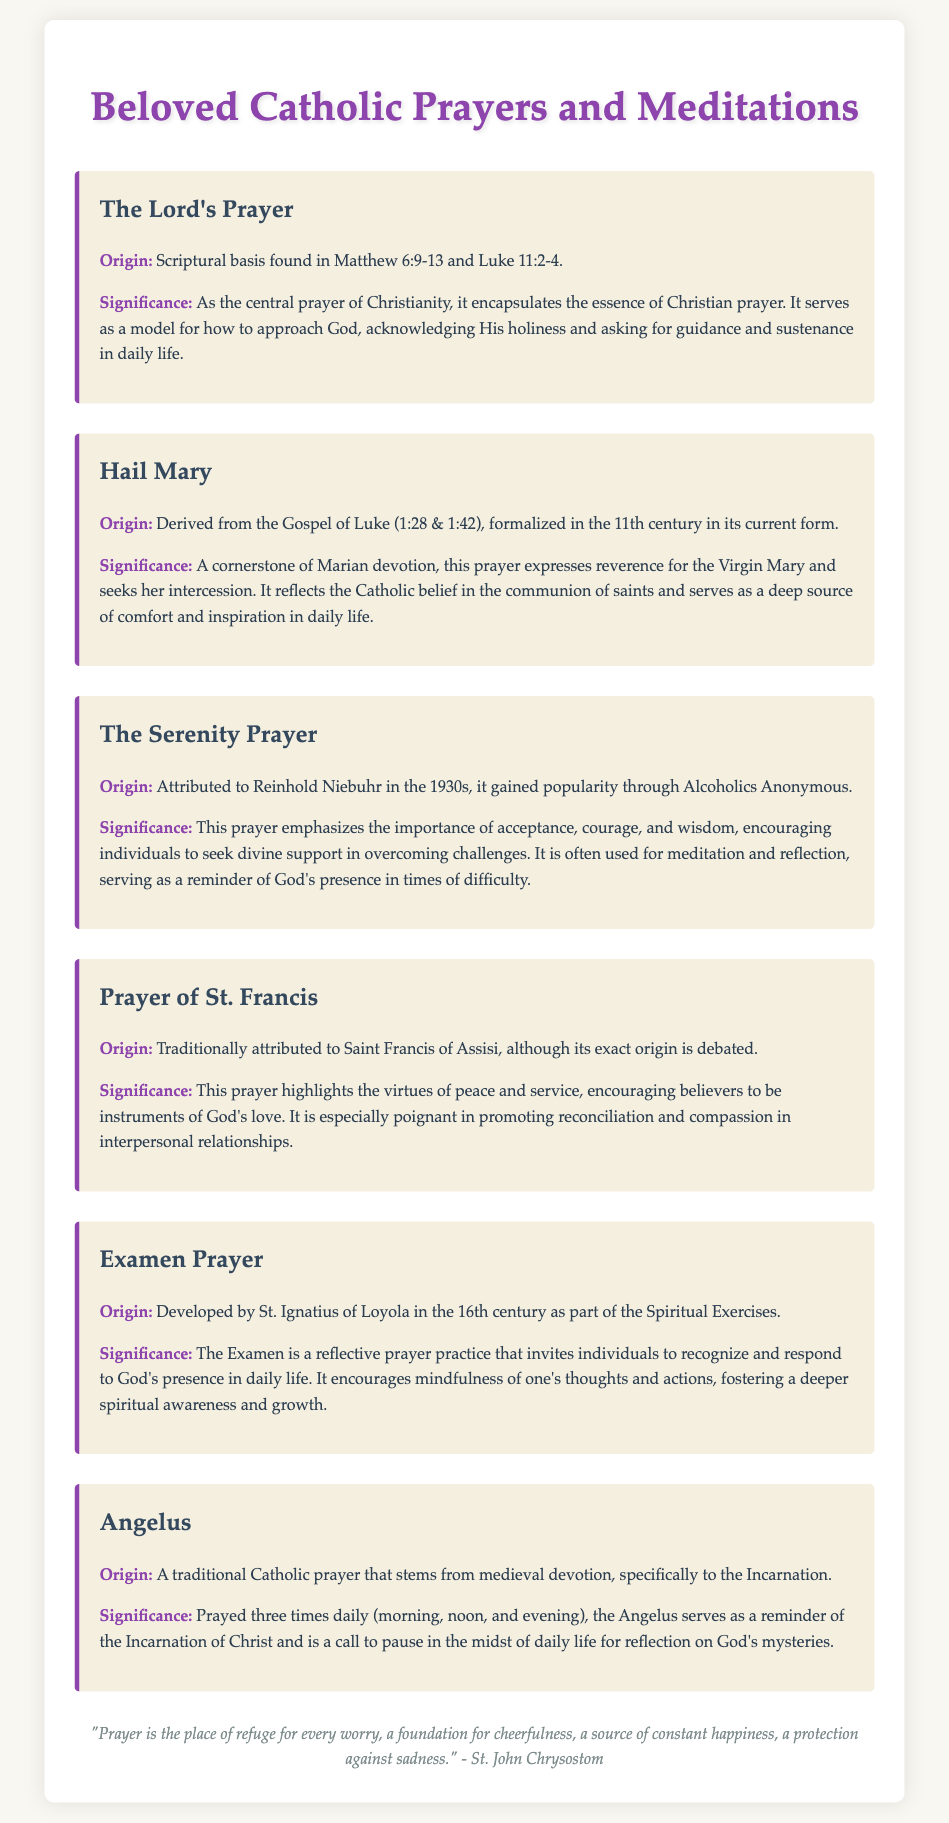What is the first prayer listed? The first prayer listed in the document is "The Lord's Prayer."
Answer: The Lord's Prayer Who is attributed to the Serenity Prayer? The Serenity Prayer is attributed to Reinhold Niebuhr.
Answer: Reinhold Niebuhr What is the origin of the Hail Mary prayer? The Hail Mary prayer’s origin is derived from the Gospel of Luke (1:28 & 1:42).
Answer: Gospel of Luke How many times a day is the Angelus prayed? The Angelus is prayed three times daily.
Answer: Three times What does the Examen Prayer encourage? The Examen Prayer encourages individuals to recognize and respond to God's presence.
Answer: Recognize and respond to God's presence Which prayer is traditionally attributed to Saint Francis of Assisi? The prayer traditionally attributed to Saint Francis of Assisi is the "Prayer of St. Francis."
Answer: Prayer of St. Francis What significance does the Angelus have in daily life? The Angelus serves as a reminder of the Incarnation of Christ.
Answer: Reminder of the Incarnation of Christ What type of document is this? This document is a compilation of favorite prayers and meditations.
Answer: Compilation of favorite prayers and meditations What color is used for the title in the document? The color used for the title is #8e44ad.
Answer: #8e44ad 